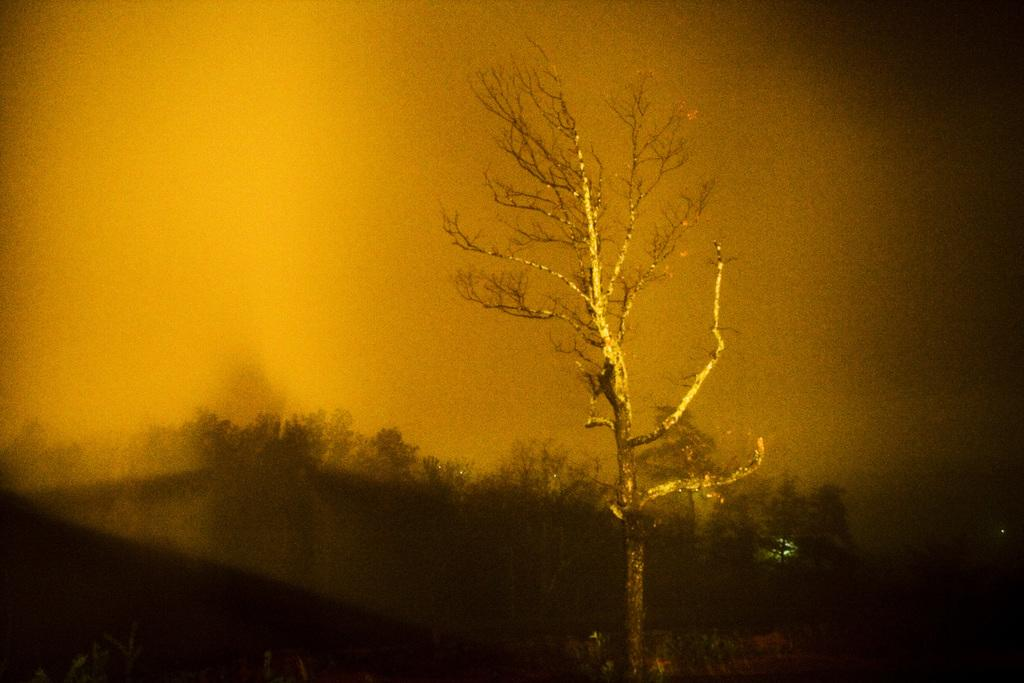What type of vegetation can be seen in the image? There are trees in the image. What is the color of the background in the image? The background color is golden yellow. What type of eyes can be seen on the trees in the image? There are no eyes present on the trees in the image. What is the pencil used for in the image? There is no pencil present in the image. 